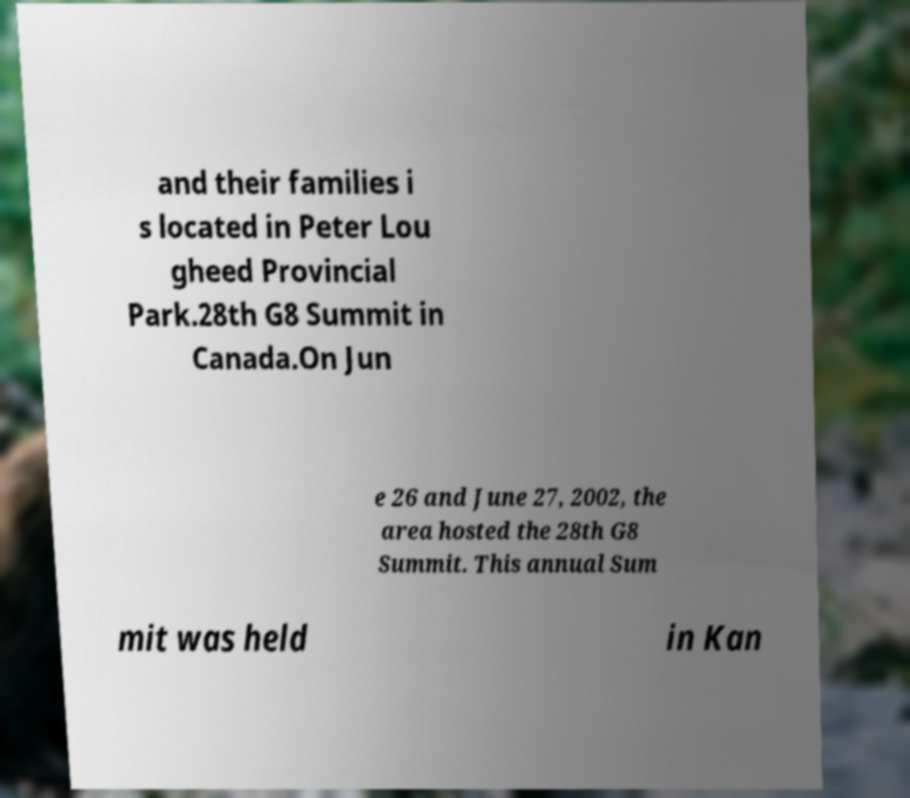There's text embedded in this image that I need extracted. Can you transcribe it verbatim? and their families i s located in Peter Lou gheed Provincial Park.28th G8 Summit in Canada.On Jun e 26 and June 27, 2002, the area hosted the 28th G8 Summit. This annual Sum mit was held in Kan 